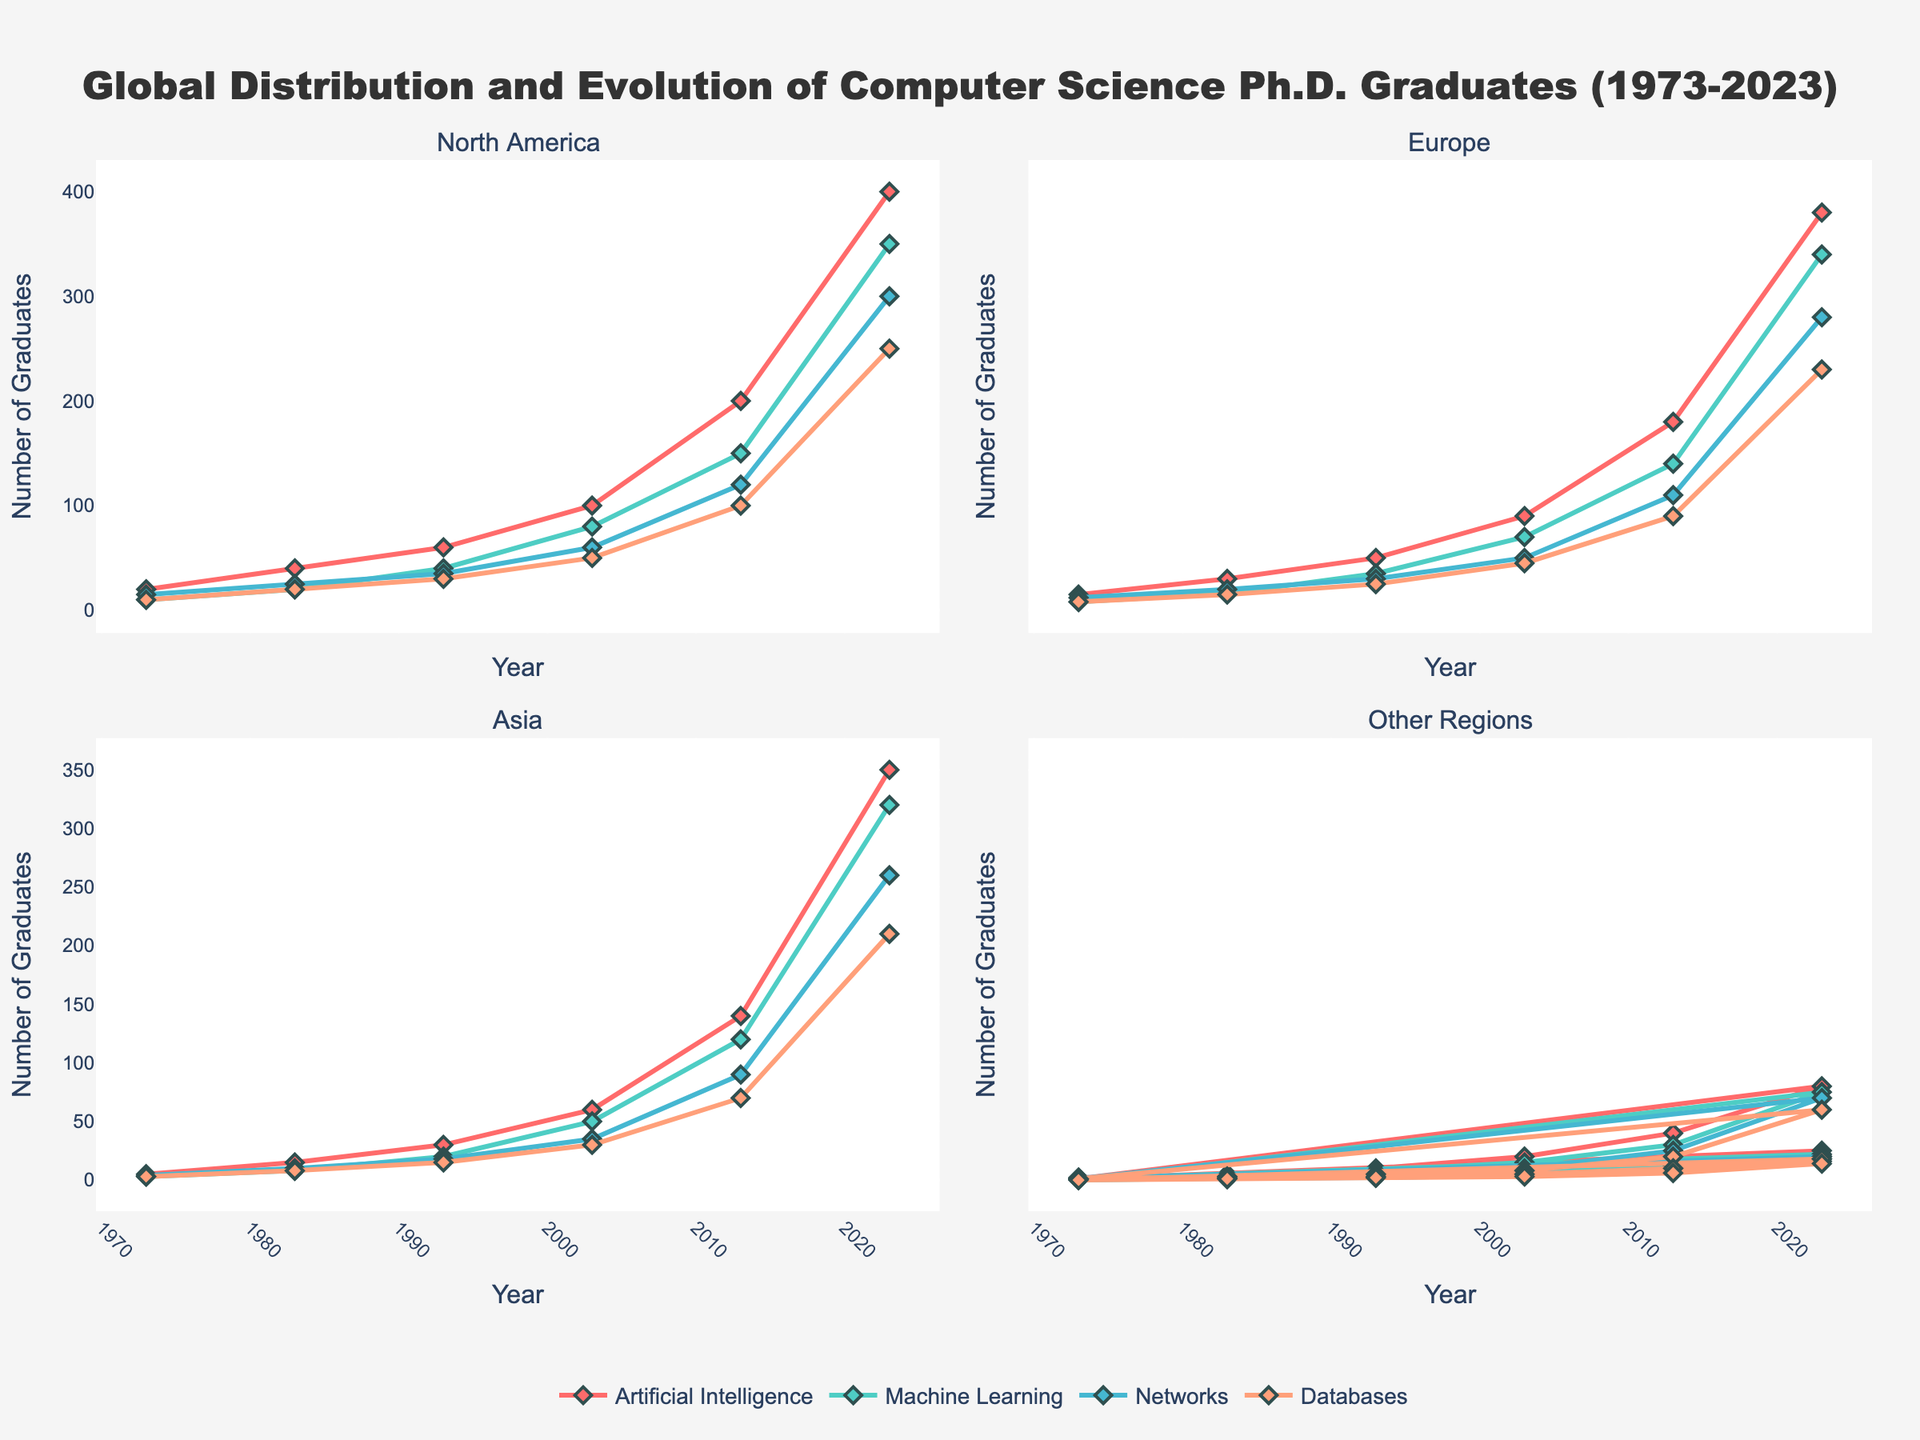what is the title of the figure? The title is usually at the top of the figure. It provides an overview of what the figure is about.
Answer: Global Distribution and Evolution of Computer Science Ph.D. Graduates (1973-2023) How many specializations are represented in the plots? Count the different lines in any of the subplots, each representing a unique specialization. There should be four distinct lines.
Answer: Four Which region had the highest number of Ph.D. graduates in Machine Learning in 2023? Look for the Machine Learning line in each subplot at the 2023 mark and compare the heights. North America has the highest with 350 graduates.
Answer: North America What was the trend in the number of AI Ph.D. graduates in Europe from 1973 to 2023? Observe the AI line in the Europe subplot. It shows a consistent upward trend from 15 in 1973 to 380 in 2023.
Answer: Upward trend What is the average number of Ph.D. graduates in Databases in Asia over the displayed years? Sum the number of Databases graduates in Asia across all displayed years and divide by the number of years listed. (3+8+15+30+70+210)/6 = 56
Answer: 56 In which year did North America see the biggest jump in AI Ph.D. graduates? Compare the AI line's year-to-year increments in the North America subplot. The biggest jump is between 2013 and 2023, from 200 to 400 graduates.
Answer: 2023 Which specialization had the least number of Ph.D. graduates in Oceania in 1983? Compare the number of graduates across specializations in 1983 in the Oceania subplot. Databases and AI have the least with 2 graduates each.
Answer: Databases and AI How did the number of Networks Ph.D. graduates in South America change between 1973 and 1993? Check the Networks line in the South America subplot between 1973 and 1993. It increased from 2 to 7 graduates.
Answer: Increased Compare the growth of Ph.D. graduates in Machine Learning between North America and Europe from 1973 to 2023. Look at the Machine Learning line in both North America and Europe subplots and note the growth. Both regions saw a similar increase, North America from 10 to 350, and Europe from 8 to 340.
Answer: Similar growth What is the predominant trend in the number of Ph.D. graduates across all specializations in South America? Observe all lines in the South America subplot. All specializations show an increasing trend over the years.
Answer: Increasing trend 